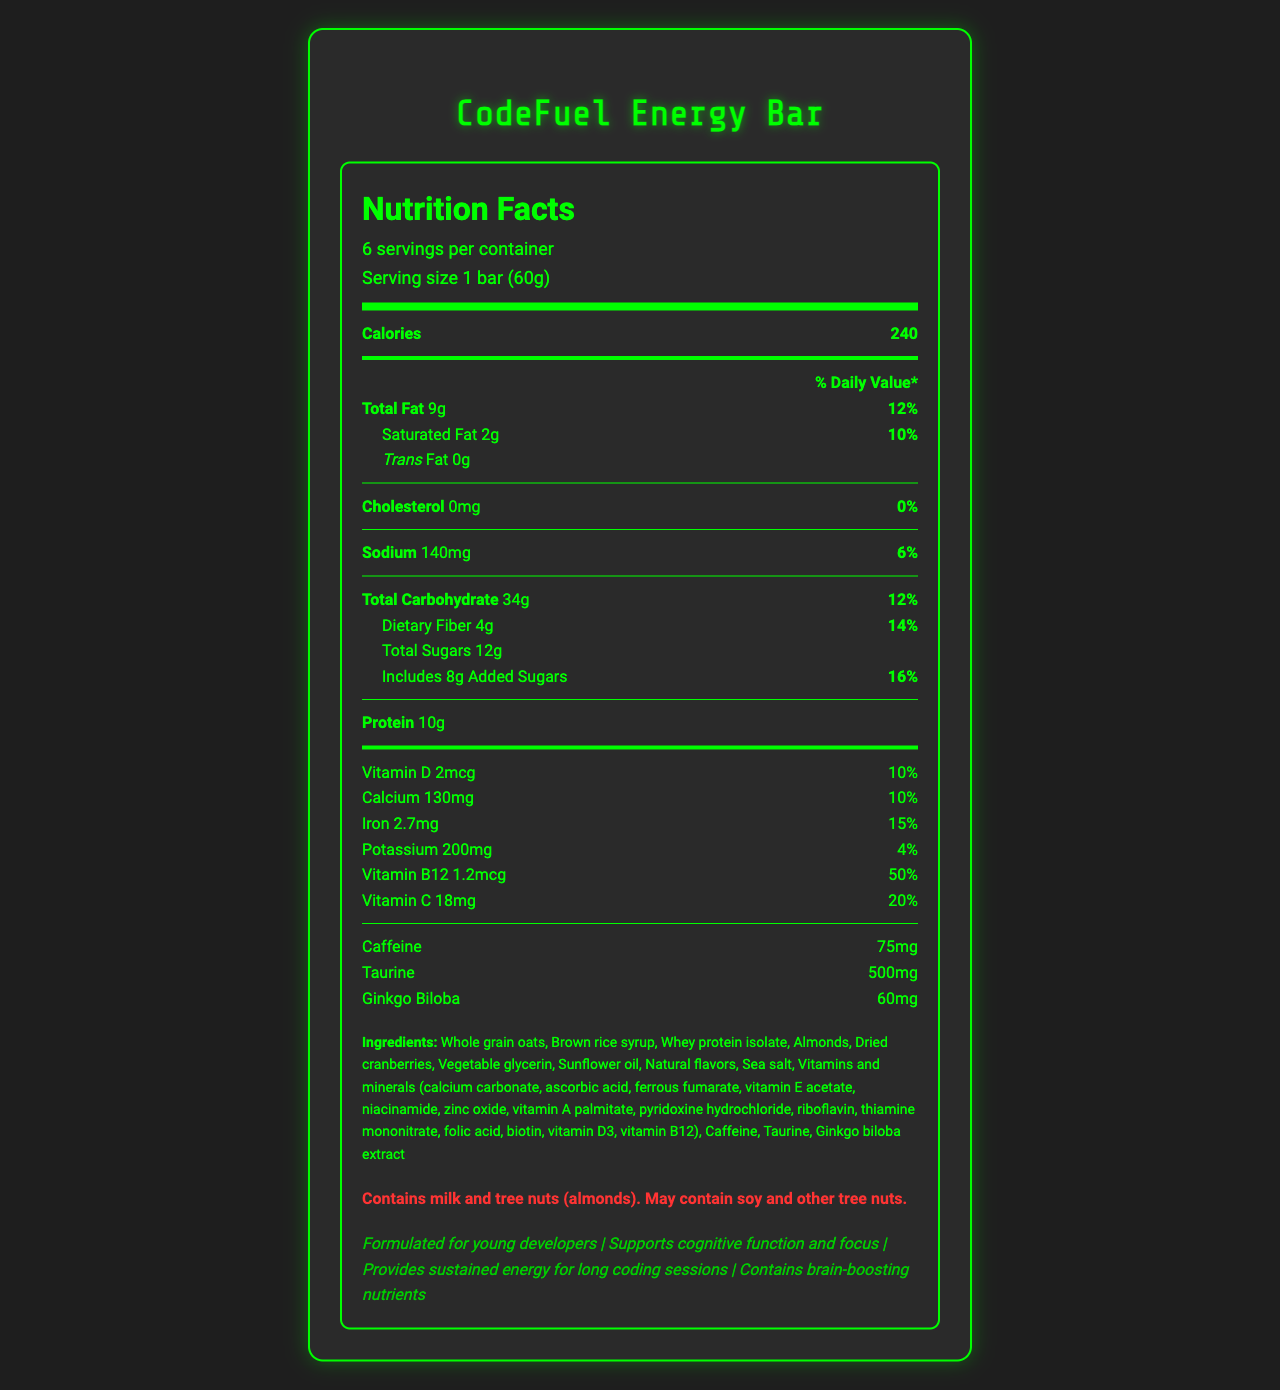what is the serving size? The serving size is directly listed under the serving information which states "Serving size 1 bar (60g)".
Answer: 1 bar (60g) how many calories are in one serving? Located at the top of the nutrition label, it mentions "Calories 240".
Answer: 240 calories what percentage of daily value is for total fat? The percentage daily value for total fat is provided next to the amount, which is 12%.
Answer: 12% how much vitamin B12 is in the bar? The nutrient section lists Vitamin B12 content as 1.2mcg with a daily value of 50%.
Answer: 1.2mcg what are the two main ingredients? The ingredients list begins with "Whole grain oats" and "Brown rice syrup", indicating they are the primary ingredients.
Answer: Whole grain oats, Brown rice syrup how many servings are there per container? A. 4 B. 6 C. 8 D. 10 The serving info states 6 servings per container.
Answer: B. 6 what is the amount of added sugars? A. 16g B. 14g C. 12g D. 8g The document specifies "Includes 8g Added Sugars".
Answer: D. 8g Is this product suitable for people with nut allergies? Yes/No The allergen info section clearly states "Contains milk and tree nuts (almonds). May contain soy and other tree nuts."
Answer: No summarize the main features of the CodeFuel Energy Bar from the document The summary encapsulates the key aspects of the product such as its target consumer, nutritional content, special ingredients, marketing claims, and allergen warnings.
Answer: The CodeFuel Energy Bar is a vitamin-fortified snack designed for young app developers, providing energy and cognitive support. It contains 240 calories per bar with nutrients like protein, fiber, and several vitamins, including high levels of Vitamin B12 and Vitamin C. It also has added functional ingredients like caffeine, taurine, and ginkgo biloba. The bar includes multiple health claims and alerts for allergens such as milk and tree nuts. what is the amount of total carbohydrate in each serving? The nutrient section specifies "Total Carbohydrate 34g".
Answer: 34g what special ingredients are included for cognitive support? The nutrient section lists these as additional supplements.
Answer: Caffeine, Taurine, Ginkgo Biloba How much caffeine does one bar contain? The amount of caffeine is directly listed in the nutrient section as 75mg.
Answer: 75mg does the bar contain any cholesterol? A. Yes B. No The document lists "Cholesterol 0mg" under the nutrient section.
Answer: B. No what is the percentage of daily value for iron? The nutrient section states iron has a daily value of 15%.
Answer: 15% What is the exact amount of Vitamin D in the bar? It is listed in the nutrient section as "Vitamin D 2mcg".
Answer: 2mcg Are there any artificial flavors in the bar? The document only states "Natural flavors" but does not provide explicit information about the absence or presence of artificial flavors.
Answer: Cannot be determined 